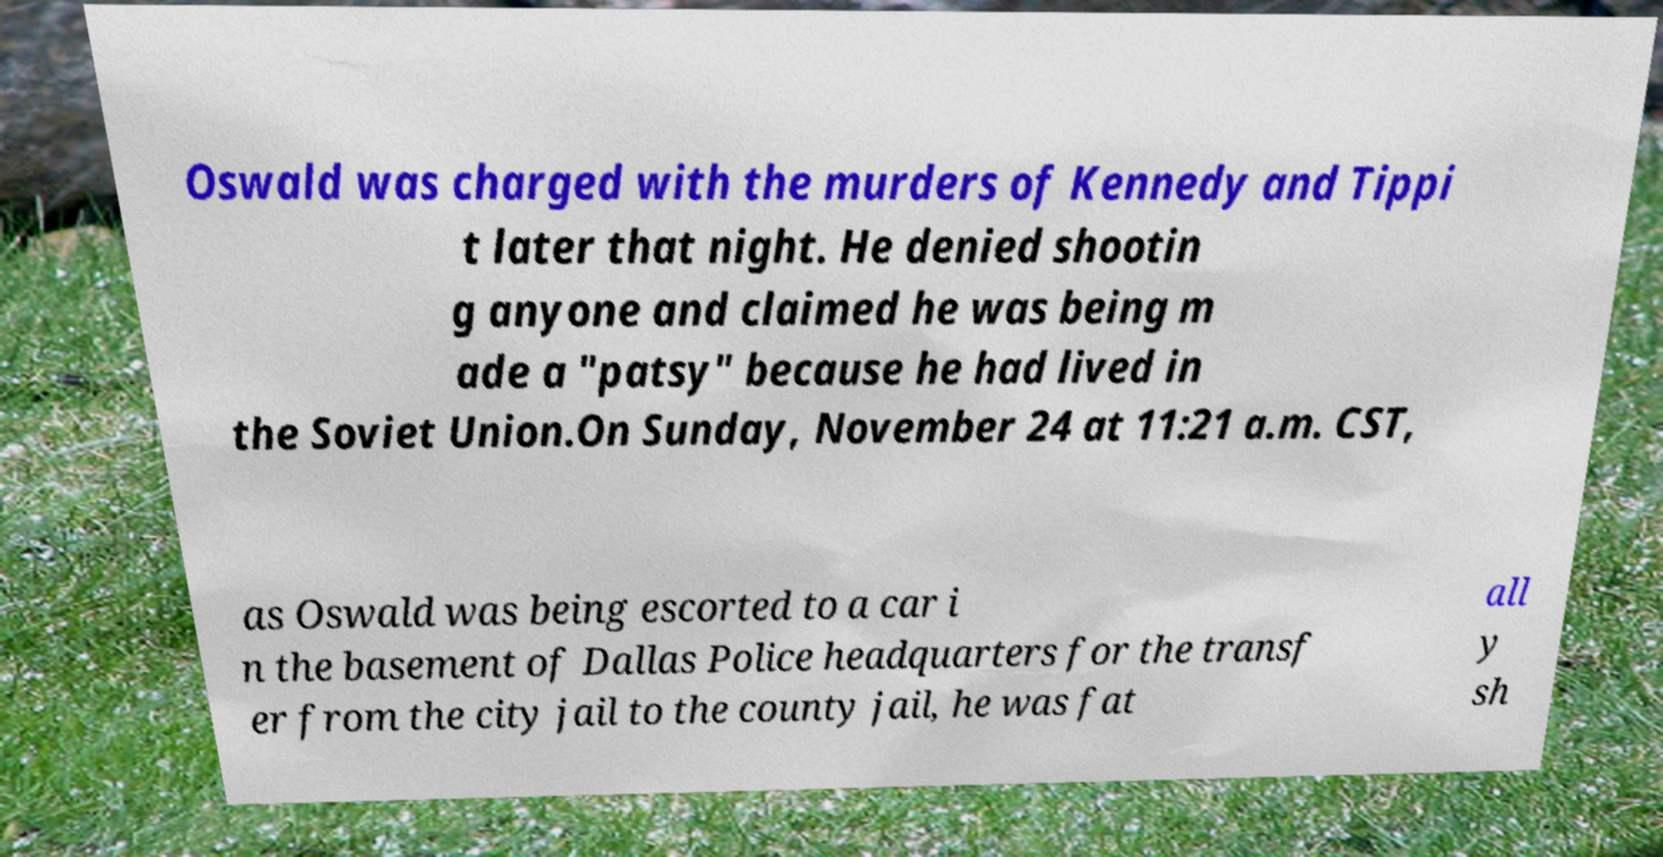There's text embedded in this image that I need extracted. Can you transcribe it verbatim? Oswald was charged with the murders of Kennedy and Tippi t later that night. He denied shootin g anyone and claimed he was being m ade a "patsy" because he had lived in the Soviet Union.On Sunday, November 24 at 11:21 a.m. CST, as Oswald was being escorted to a car i n the basement of Dallas Police headquarters for the transf er from the city jail to the county jail, he was fat all y sh 